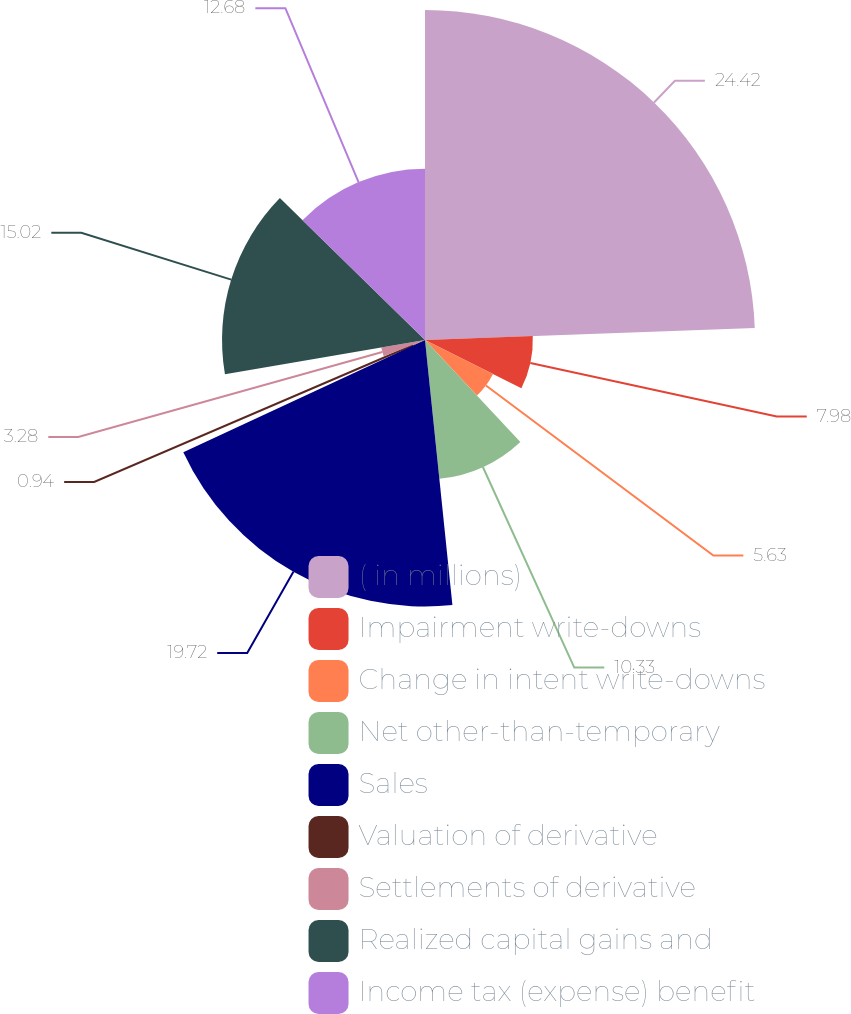Convert chart. <chart><loc_0><loc_0><loc_500><loc_500><pie_chart><fcel>( in millions)<fcel>Impairment write-downs<fcel>Change in intent write-downs<fcel>Net other-than-temporary<fcel>Sales<fcel>Valuation of derivative<fcel>Settlements of derivative<fcel>Realized capital gains and<fcel>Income tax (expense) benefit<nl><fcel>24.42%<fcel>7.98%<fcel>5.63%<fcel>10.33%<fcel>19.72%<fcel>0.94%<fcel>3.28%<fcel>15.02%<fcel>12.68%<nl></chart> 